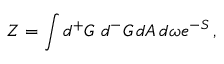<formula> <loc_0><loc_0><loc_500><loc_500>Z = \int d { ^ { + } G } \, d { ^ { - } G } \, d A \, d \omega e ^ { - S } \, ,</formula> 